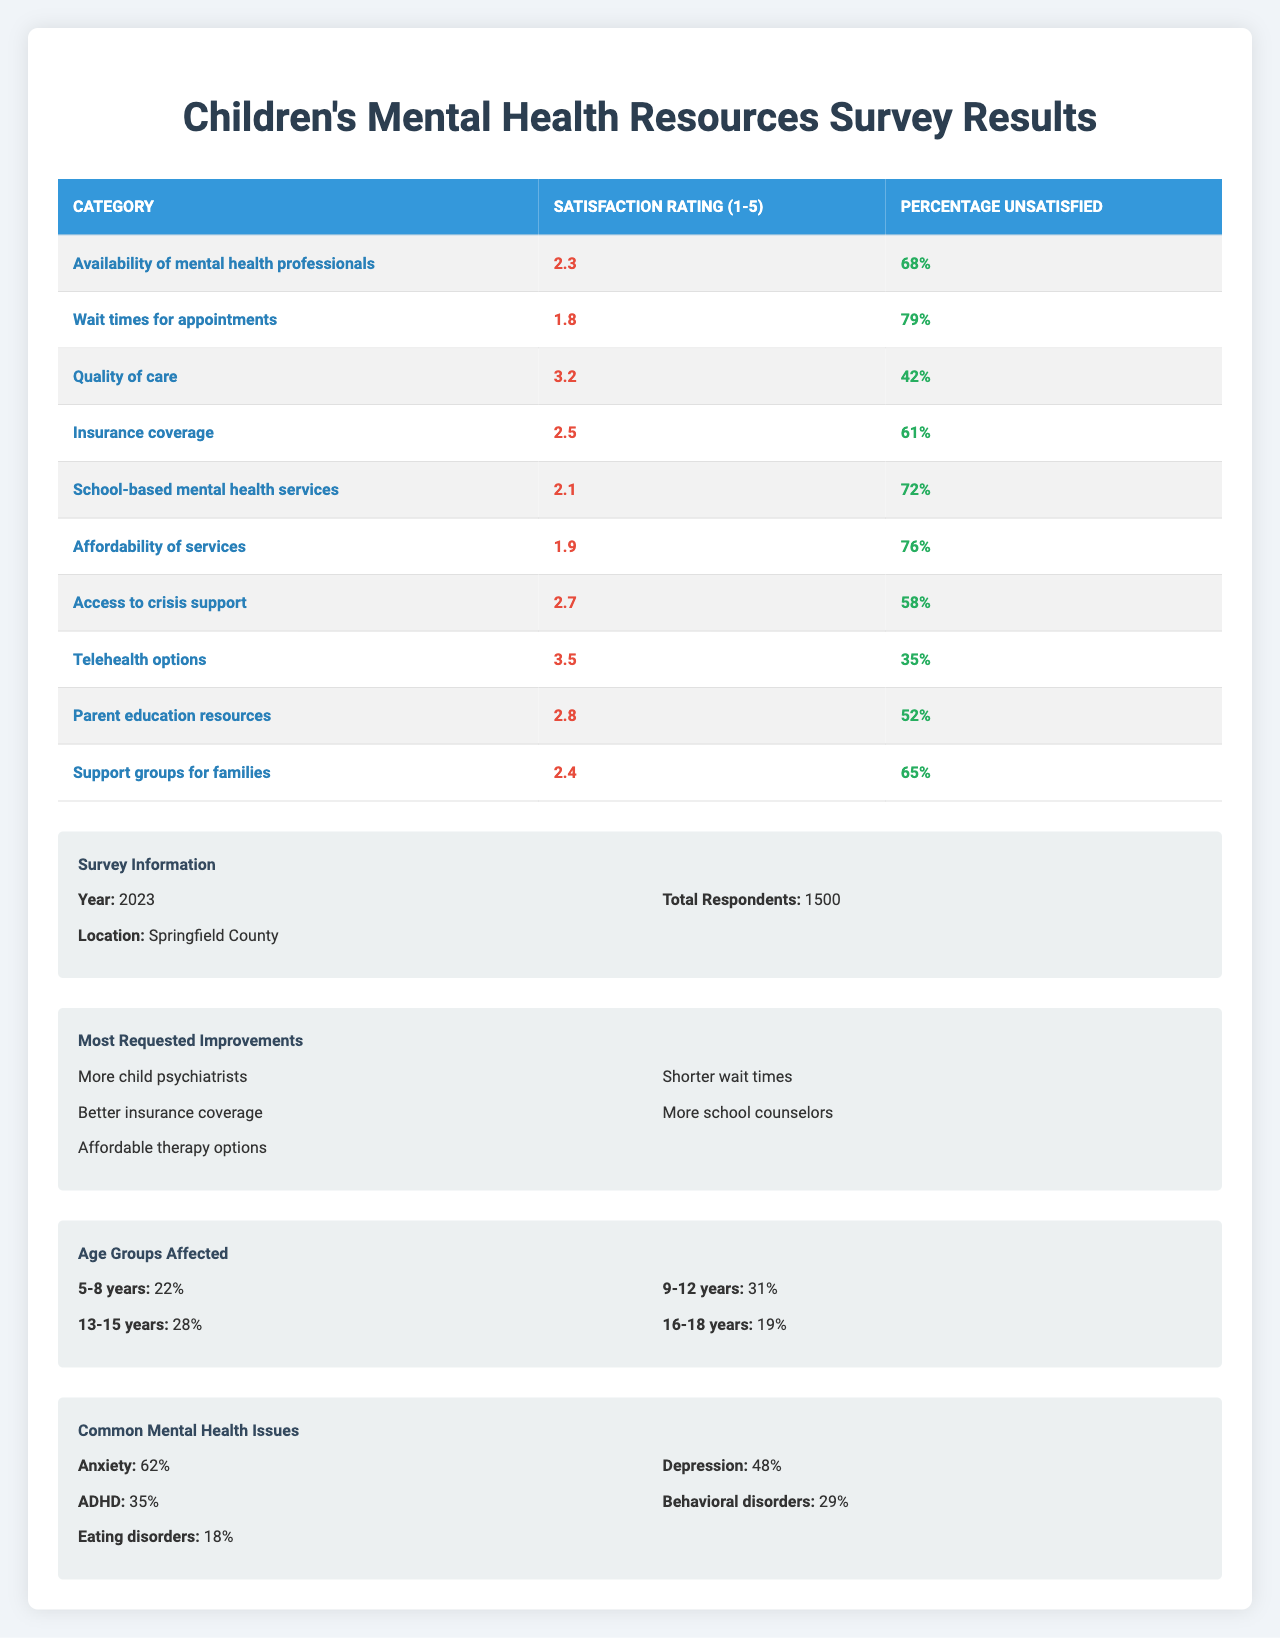What is the satisfaction rating for "School-based mental health services"? The satisfaction rating is listed in the table under the specific category "School-based mental health services," which is 2.1.
Answer: 2.1 What percentage of parents are unsatisfied with the availability of mental health professionals? The percentage unsatisfied is found in the corresponding column for "Availability of mental health professionals," which is 68%.
Answer: 68% Which category has the highest satisfaction rating? By comparing all the satisfaction ratings across categories, the highest rating is found under "Telehealth options," which is 3.5.
Answer: Telehealth options What is the average satisfaction rating across all categories? First, sum all the satisfaction ratings: 2.3 + 1.8 + 3.2 + 2.5 + 2.1 + 1.9 + 2.7 + 3.5 + 2.8 + 2.4 = 24.1. Then, divide by the number of categories (10) to get the average: 24.1 / 10 = 2.41.
Answer: 2.41 How many categories have a satisfaction rating below 2.0? Reviewing the satisfaction ratings, we find that "Wait times for appointments" (1.8), "Affordability of services" (1.9) are below 2.0, making it a total of 2 categories.
Answer: 2 Is the percentage of unsatisfied parents greater than 75% for any category? Consulting the "Percentage Unsatisfied" column, we see that "Wait times for appointments" (79%) and "Affordability of services" (76%) both exceed 75%.
Answer: Yes What percentage of parents reported anxiety as a common mental health issue? The percentage reporting anxiety is found in the table under "Common Mental Health Issues," which shows a figure of 62%.
Answer: 62% Which age group has the highest percentage affected, and what is that percentage? Checking the "Age Groups Affected" section, the highest percentage is for the 9-12 years group, which represents 31%.
Answer: 9-12 years, 31% What are the most requested improvements that focus on affordability? The table lists several requested improvements, and "Affordable therapy options" is explicitly centered on affordability.
Answer: Affordable therapy options What is the difference between the percentage of parents who reported depression and those who reported ADHD? The percentage for depression is 48%, while ADHD is 35%. The difference is calculated by subtracting 35 from 48, resulting in 13%.
Answer: 13% 